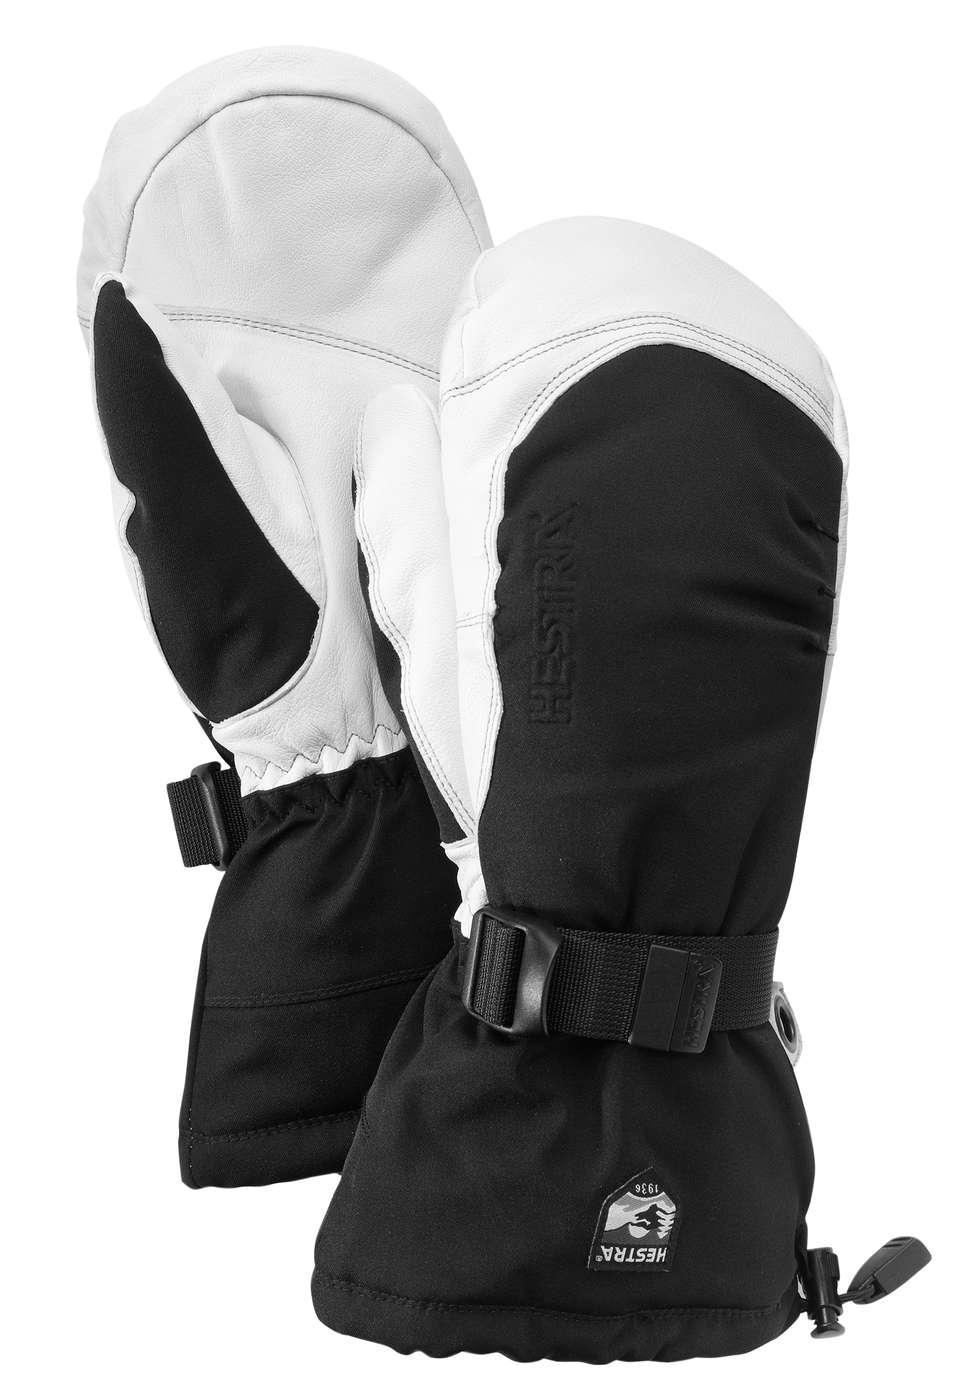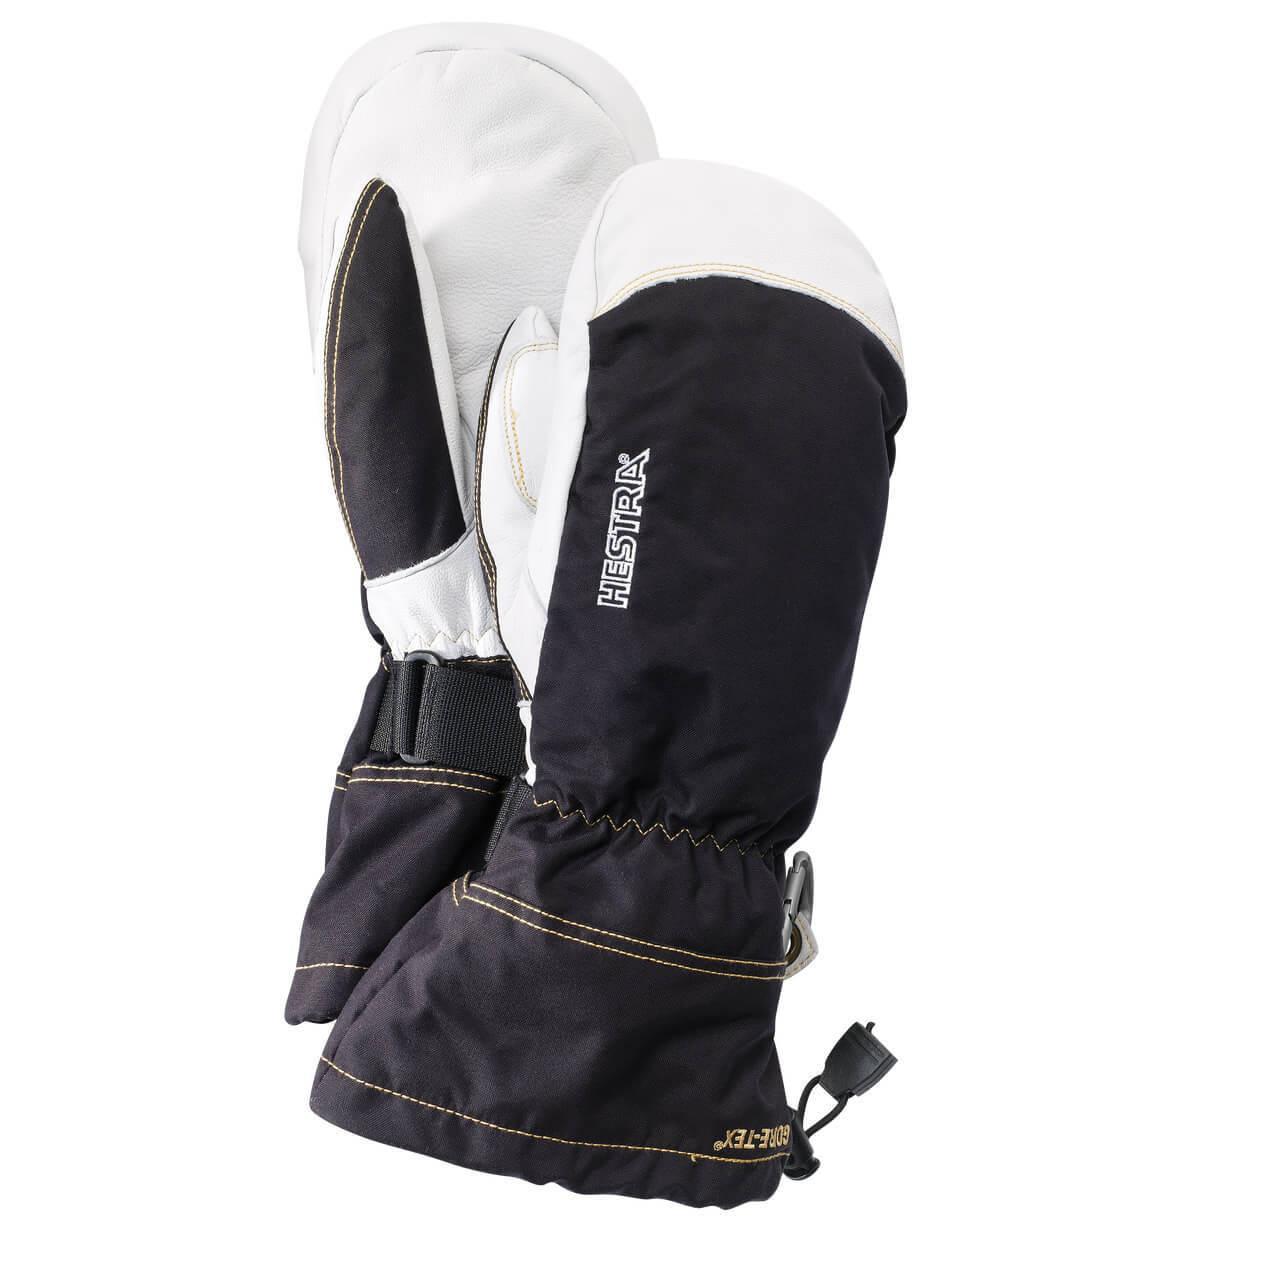The first image is the image on the left, the second image is the image on the right. Considering the images on both sides, is "Every mitten has a white tip and palm." valid? Answer yes or no. Yes. The first image is the image on the left, the second image is the image on the right. Considering the images on both sides, is "There is a pair of brown leather mittens in one of the images." valid? Answer yes or no. No. 